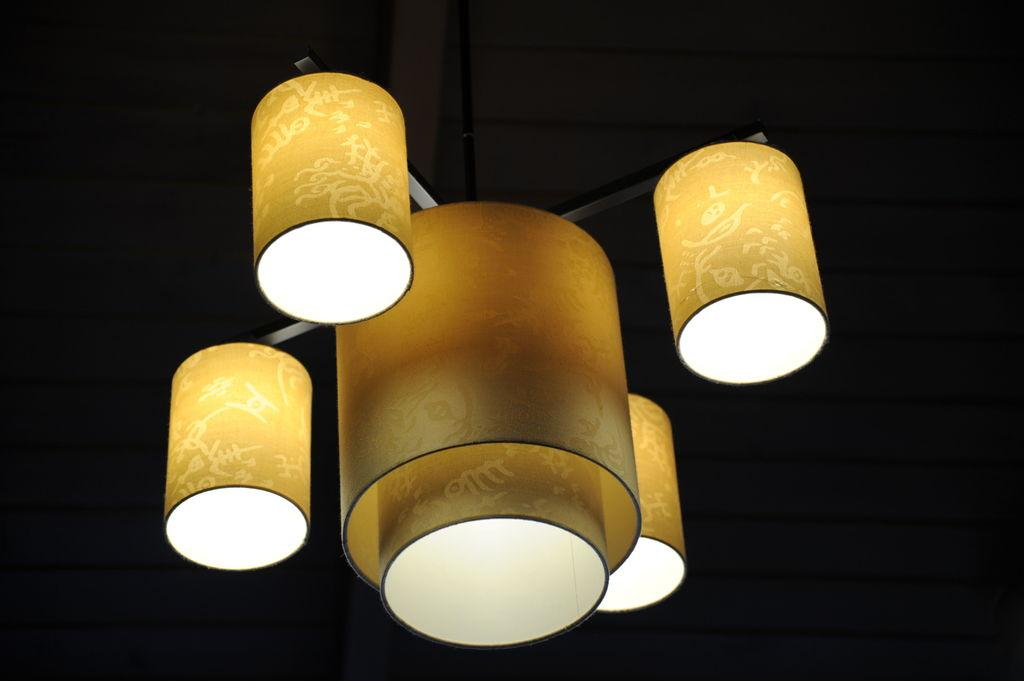What is present in the image that provides illumination? There are lights in the image. How would you describe the overall lighting condition in the image? The background of the image is dark. What color of chalk is being used to draw on the thread in the image? There is no chalk or thread present in the image, so this question cannot be answered. 